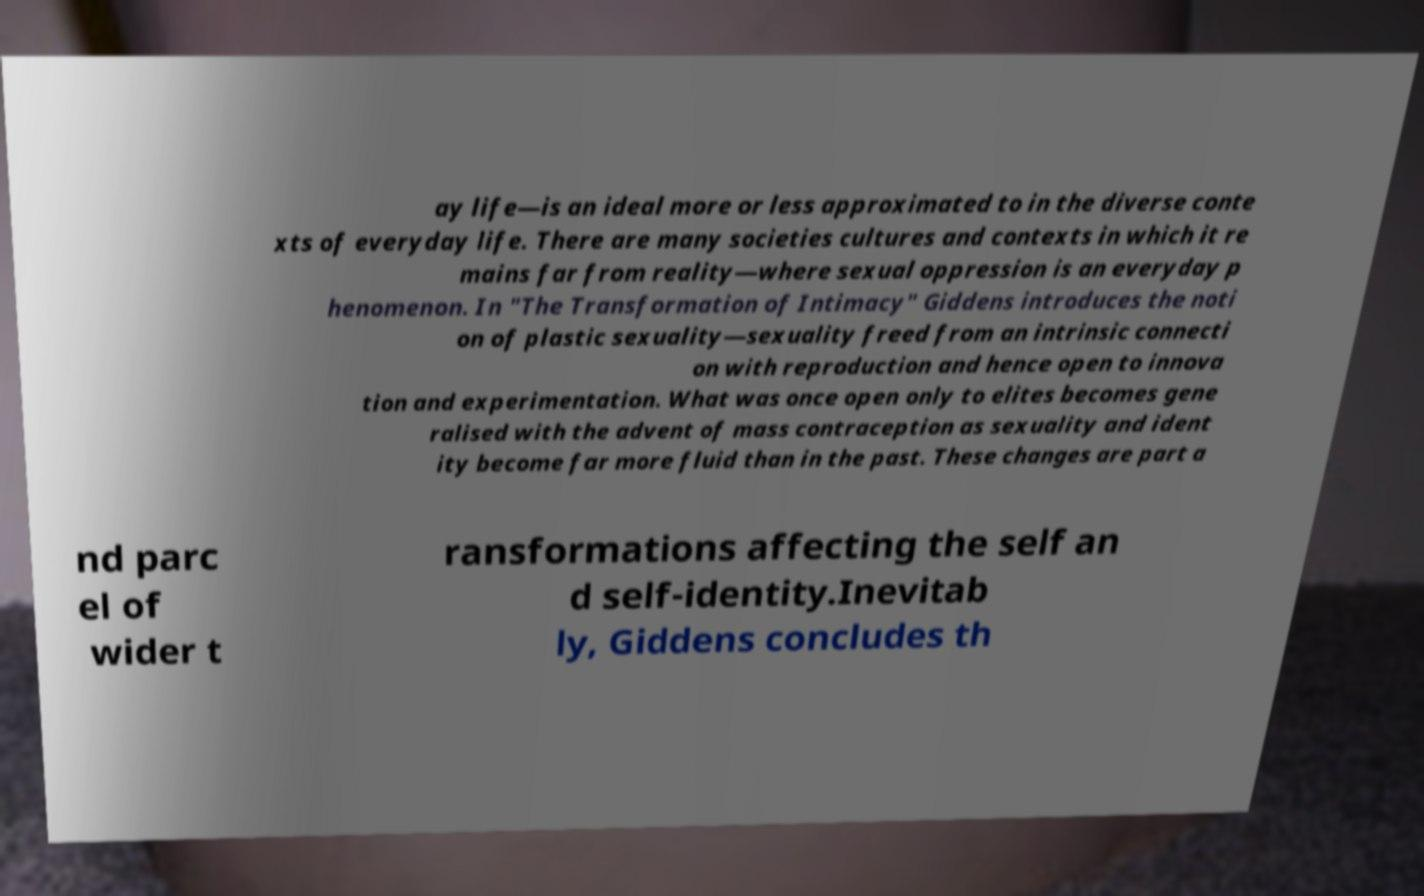Please identify and transcribe the text found in this image. ay life—is an ideal more or less approximated to in the diverse conte xts of everyday life. There are many societies cultures and contexts in which it re mains far from reality—where sexual oppression is an everyday p henomenon. In "The Transformation of Intimacy" Giddens introduces the noti on of plastic sexuality—sexuality freed from an intrinsic connecti on with reproduction and hence open to innova tion and experimentation. What was once open only to elites becomes gene ralised with the advent of mass contraception as sexuality and ident ity become far more fluid than in the past. These changes are part a nd parc el of wider t ransformations affecting the self an d self-identity.Inevitab ly, Giddens concludes th 